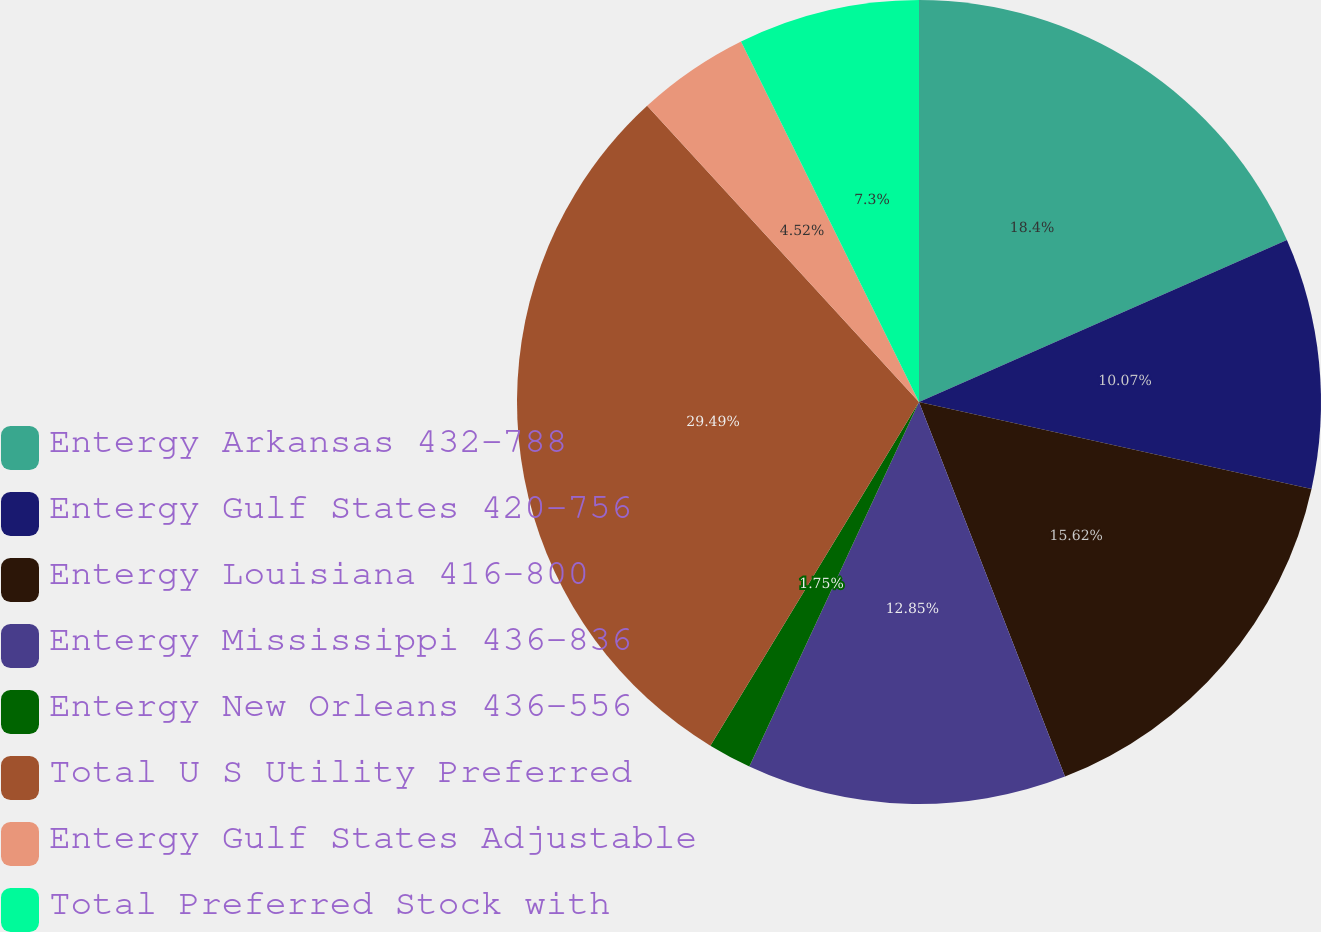<chart> <loc_0><loc_0><loc_500><loc_500><pie_chart><fcel>Entergy Arkansas 432-788<fcel>Entergy Gulf States 420-756<fcel>Entergy Louisiana 416-800<fcel>Entergy Mississippi 436-836<fcel>Entergy New Orleans 436-556<fcel>Total U S Utility Preferred<fcel>Entergy Gulf States Adjustable<fcel>Total Preferred Stock with<nl><fcel>18.4%<fcel>10.07%<fcel>15.62%<fcel>12.85%<fcel>1.75%<fcel>29.5%<fcel>4.52%<fcel>7.3%<nl></chart> 